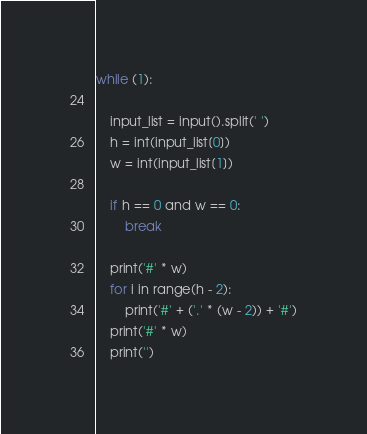Convert code to text. <code><loc_0><loc_0><loc_500><loc_500><_Python_>while (1):

    input_list = input().split(' ')
    h = int(input_list[0])
    w = int(input_list[1])

    if h == 0 and w == 0:
        break

    print('#' * w)
    for i in range(h - 2):
        print('#' + ('.' * (w - 2)) + '#')
    print('#' * w)
    print('')
</code> 